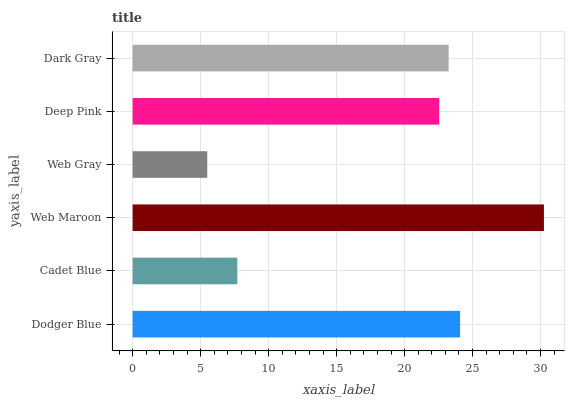Is Web Gray the minimum?
Answer yes or no. Yes. Is Web Maroon the maximum?
Answer yes or no. Yes. Is Cadet Blue the minimum?
Answer yes or no. No. Is Cadet Blue the maximum?
Answer yes or no. No. Is Dodger Blue greater than Cadet Blue?
Answer yes or no. Yes. Is Cadet Blue less than Dodger Blue?
Answer yes or no. Yes. Is Cadet Blue greater than Dodger Blue?
Answer yes or no. No. Is Dodger Blue less than Cadet Blue?
Answer yes or no. No. Is Dark Gray the high median?
Answer yes or no. Yes. Is Deep Pink the low median?
Answer yes or no. Yes. Is Dodger Blue the high median?
Answer yes or no. No. Is Dark Gray the low median?
Answer yes or no. No. 